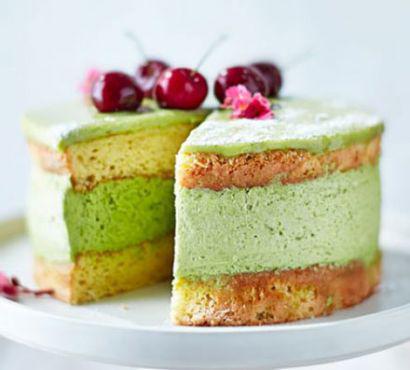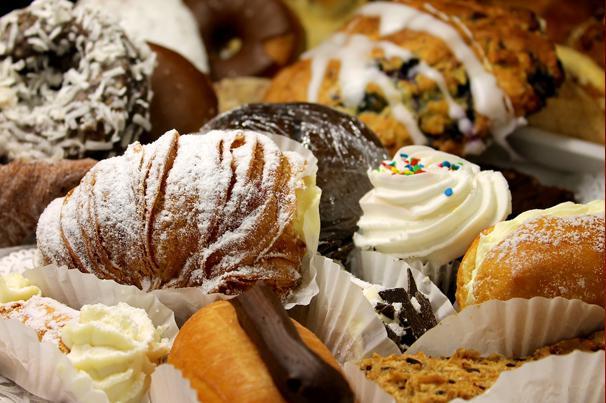The first image is the image on the left, the second image is the image on the right. Analyze the images presented: Is the assertion "The left image shows individual round desserts in rows on a tray, and at least one row of desserts have red berries on top." valid? Answer yes or no. No. The first image is the image on the left, the second image is the image on the right. Given the left and right images, does the statement "There are strawberries on top of some of the desserts." hold true? Answer yes or no. No. 